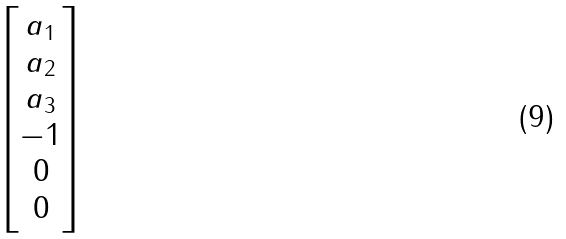Convert formula to latex. <formula><loc_0><loc_0><loc_500><loc_500>\begin{bmatrix} a _ { 1 } \\ a _ { 2 } \\ a _ { 3 } \\ - 1 \\ 0 \\ 0 \end{bmatrix}</formula> 